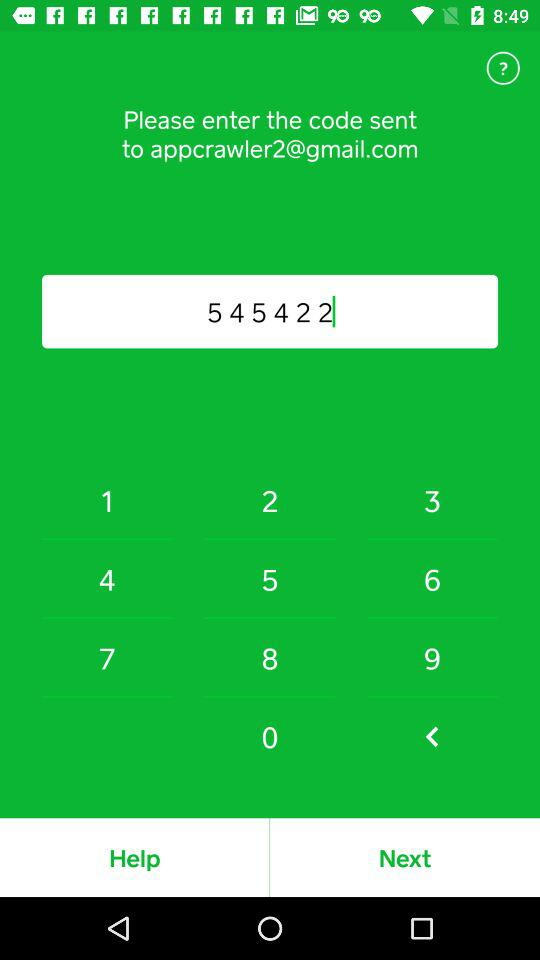What is the name of the application?
When the provided information is insufficient, respond with <no answer>. <no answer> 